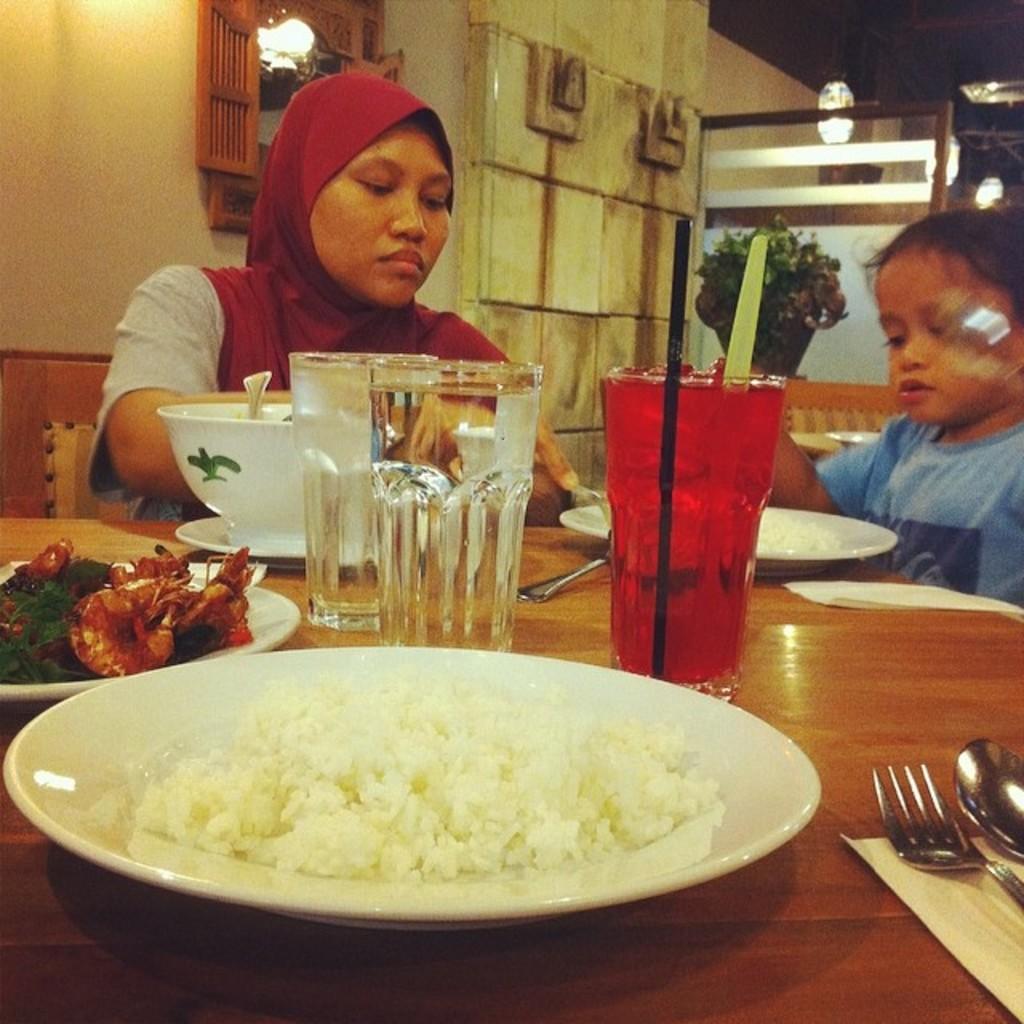Please provide a concise description of this image. There is rice on the white color plate which is on the table on which there are plates having food items, fork and spoon on a cloth, white color bowl on a white color plate, a child sitting on a chair, a woman sitting on another chair, there is a pot plate, a mirror attached to the wall and there are other objects. 